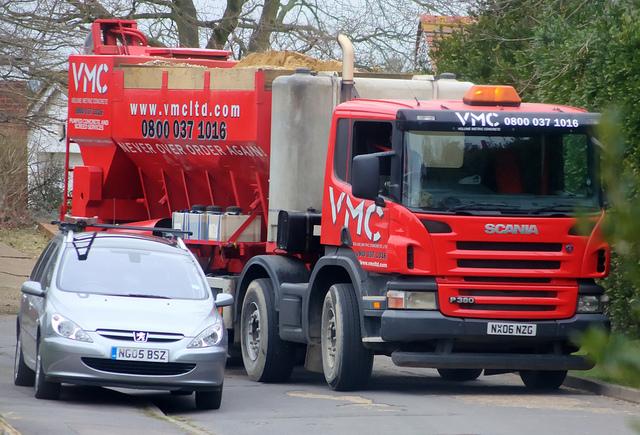Are these two vehicles on the same trajectory?
Quick response, please. Yes. What color is the truck?
Be succinct. Red. What are the two vehicles?
Write a very short answer. Truck and car. What truck company owns this?
Give a very brief answer. Vmc. What is the color of the car?
Answer briefly. Silver. Is there a trailer attached to the truck?
Be succinct. Yes. What are the numbers on the car's plates?
Be succinct. 5. What does the front of the truck say?
Concise answer only. Scania. What word is written above the truck's windshield?
Quick response, please. Vmc. Based on the phone number, what country is this?
Answer briefly. Europe. How many people are in the truck?
Short answer required. 0. What make is this truck?
Keep it brief. Scania. 